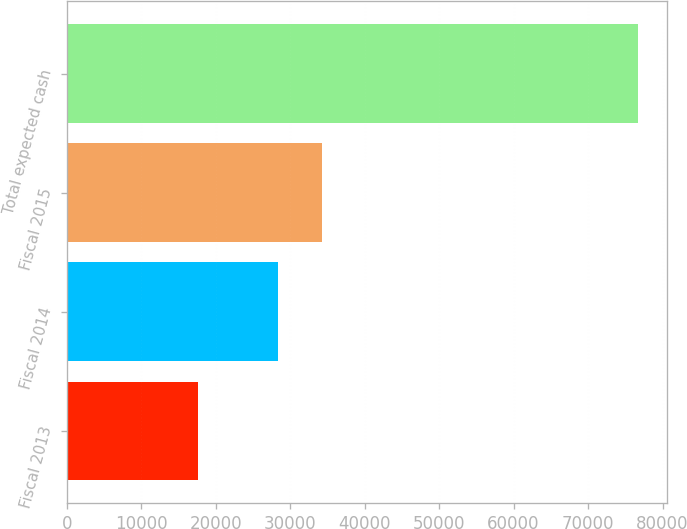Convert chart. <chart><loc_0><loc_0><loc_500><loc_500><bar_chart><fcel>Fiscal 2013<fcel>Fiscal 2014<fcel>Fiscal 2015<fcel>Total expected cash<nl><fcel>17664<fcel>28309<fcel>34214.4<fcel>76718<nl></chart> 